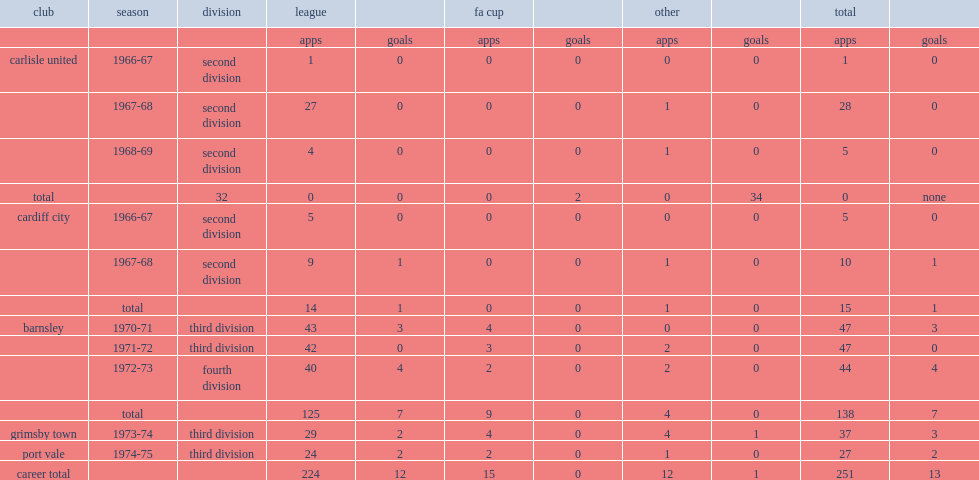How many league goals did frank sharp score for grimsby town in 1973-74? 2.0. 